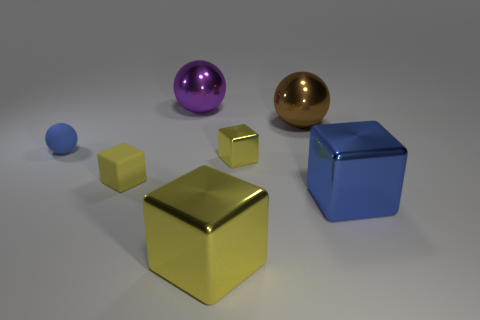There is a small rubber thing that is to the right of the tiny rubber sphere in front of the large object to the left of the large yellow metal thing; what is its color?
Offer a very short reply. Yellow. Are the blue cube and the tiny blue thing made of the same material?
Offer a terse response. No. How many green objects are big metal blocks or tiny cubes?
Provide a succinct answer. 0. There is a brown metallic thing; how many metal balls are behind it?
Your answer should be very brief. 1. Are there more yellow cubes than matte blocks?
Keep it short and to the point. Yes. There is a yellow shiny thing in front of the yellow metallic object right of the large yellow shiny block; what is its shape?
Keep it short and to the point. Cube. Is the small metallic cube the same color as the tiny matte cube?
Offer a very short reply. Yes. Are there more large metal things that are on the right side of the large brown metallic thing than tiny red matte cylinders?
Provide a succinct answer. Yes. There is a tiny rubber thing on the right side of the small matte ball; how many objects are right of it?
Provide a short and direct response. 5. Are the block that is left of the big purple shiny sphere and the small blue ball that is to the left of the purple metallic ball made of the same material?
Your answer should be compact. Yes. 